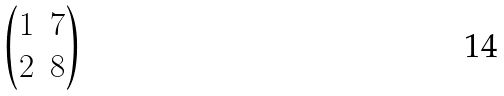<formula> <loc_0><loc_0><loc_500><loc_500>\begin{pmatrix} 1 & 7 \\ 2 & 8 \end{pmatrix}</formula> 